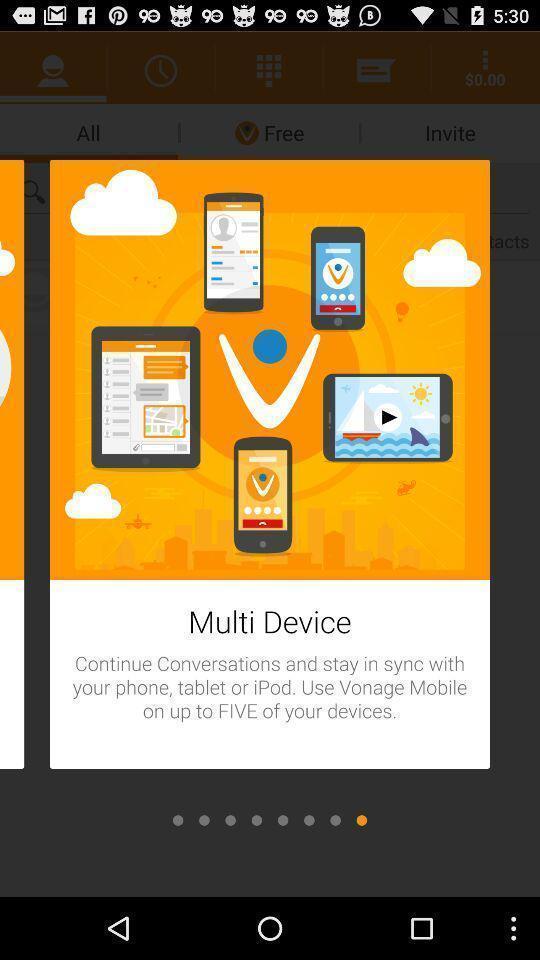Describe the key features of this screenshot. Starting page of a group conversation app. 